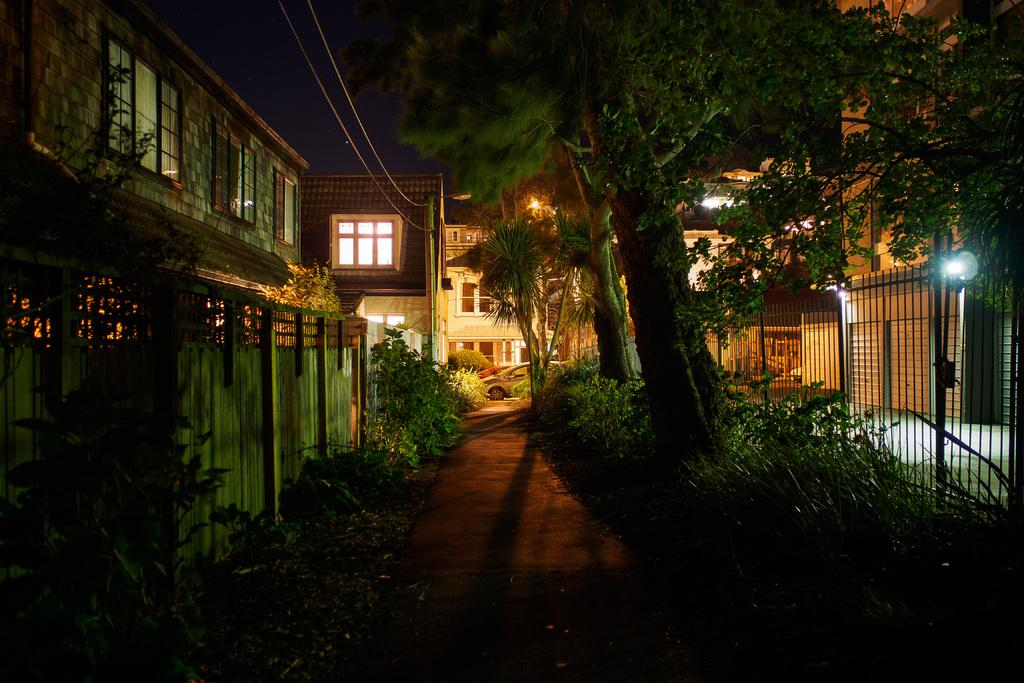What type of living organisms can be seen in the image? Plants and trees are visible in the image. What is the primary man-made structure in the image? There is a wall in the image. What other man-made structures can be seen in the image? There are buildings and poles in the image. What type of illumination is present in the image? There are lights in the image. What else can be seen in the image besides the plants, trees, and man-made structures? There are vehicles in the middle of the image. What type of pipe is visible in the image? There is no pipe present in the image. What reason do the plants have for being in the image? Plants do not have reasons; they are simply present in the image. 